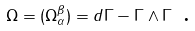<formula> <loc_0><loc_0><loc_500><loc_500>\Omega = ( \Omega _ { \alpha } ^ { \beta } ) = d \Gamma - \Gamma \wedge \Gamma \text { .}</formula> 